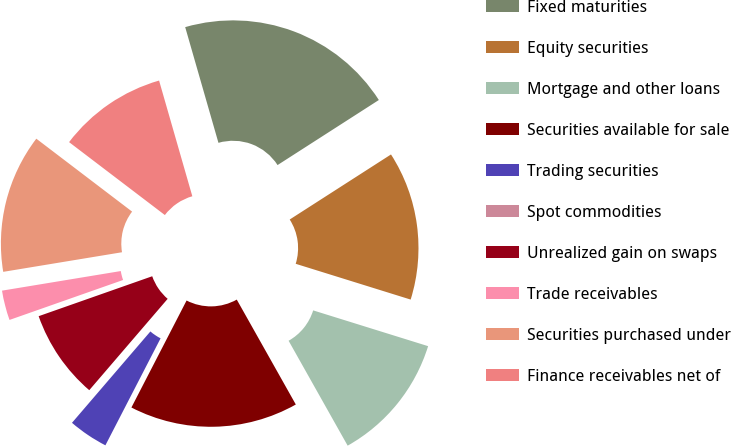Convert chart to OTSL. <chart><loc_0><loc_0><loc_500><loc_500><pie_chart><fcel>Fixed maturities<fcel>Equity securities<fcel>Mortgage and other loans<fcel>Securities available for sale<fcel>Trading securities<fcel>Spot commodities<fcel>Unrealized gain on swaps<fcel>Trade receivables<fcel>Securities purchased under<fcel>Finance receivables net of<nl><fcel>20.37%<fcel>13.89%<fcel>12.04%<fcel>15.74%<fcel>3.71%<fcel>0.0%<fcel>8.33%<fcel>2.78%<fcel>12.96%<fcel>10.19%<nl></chart> 